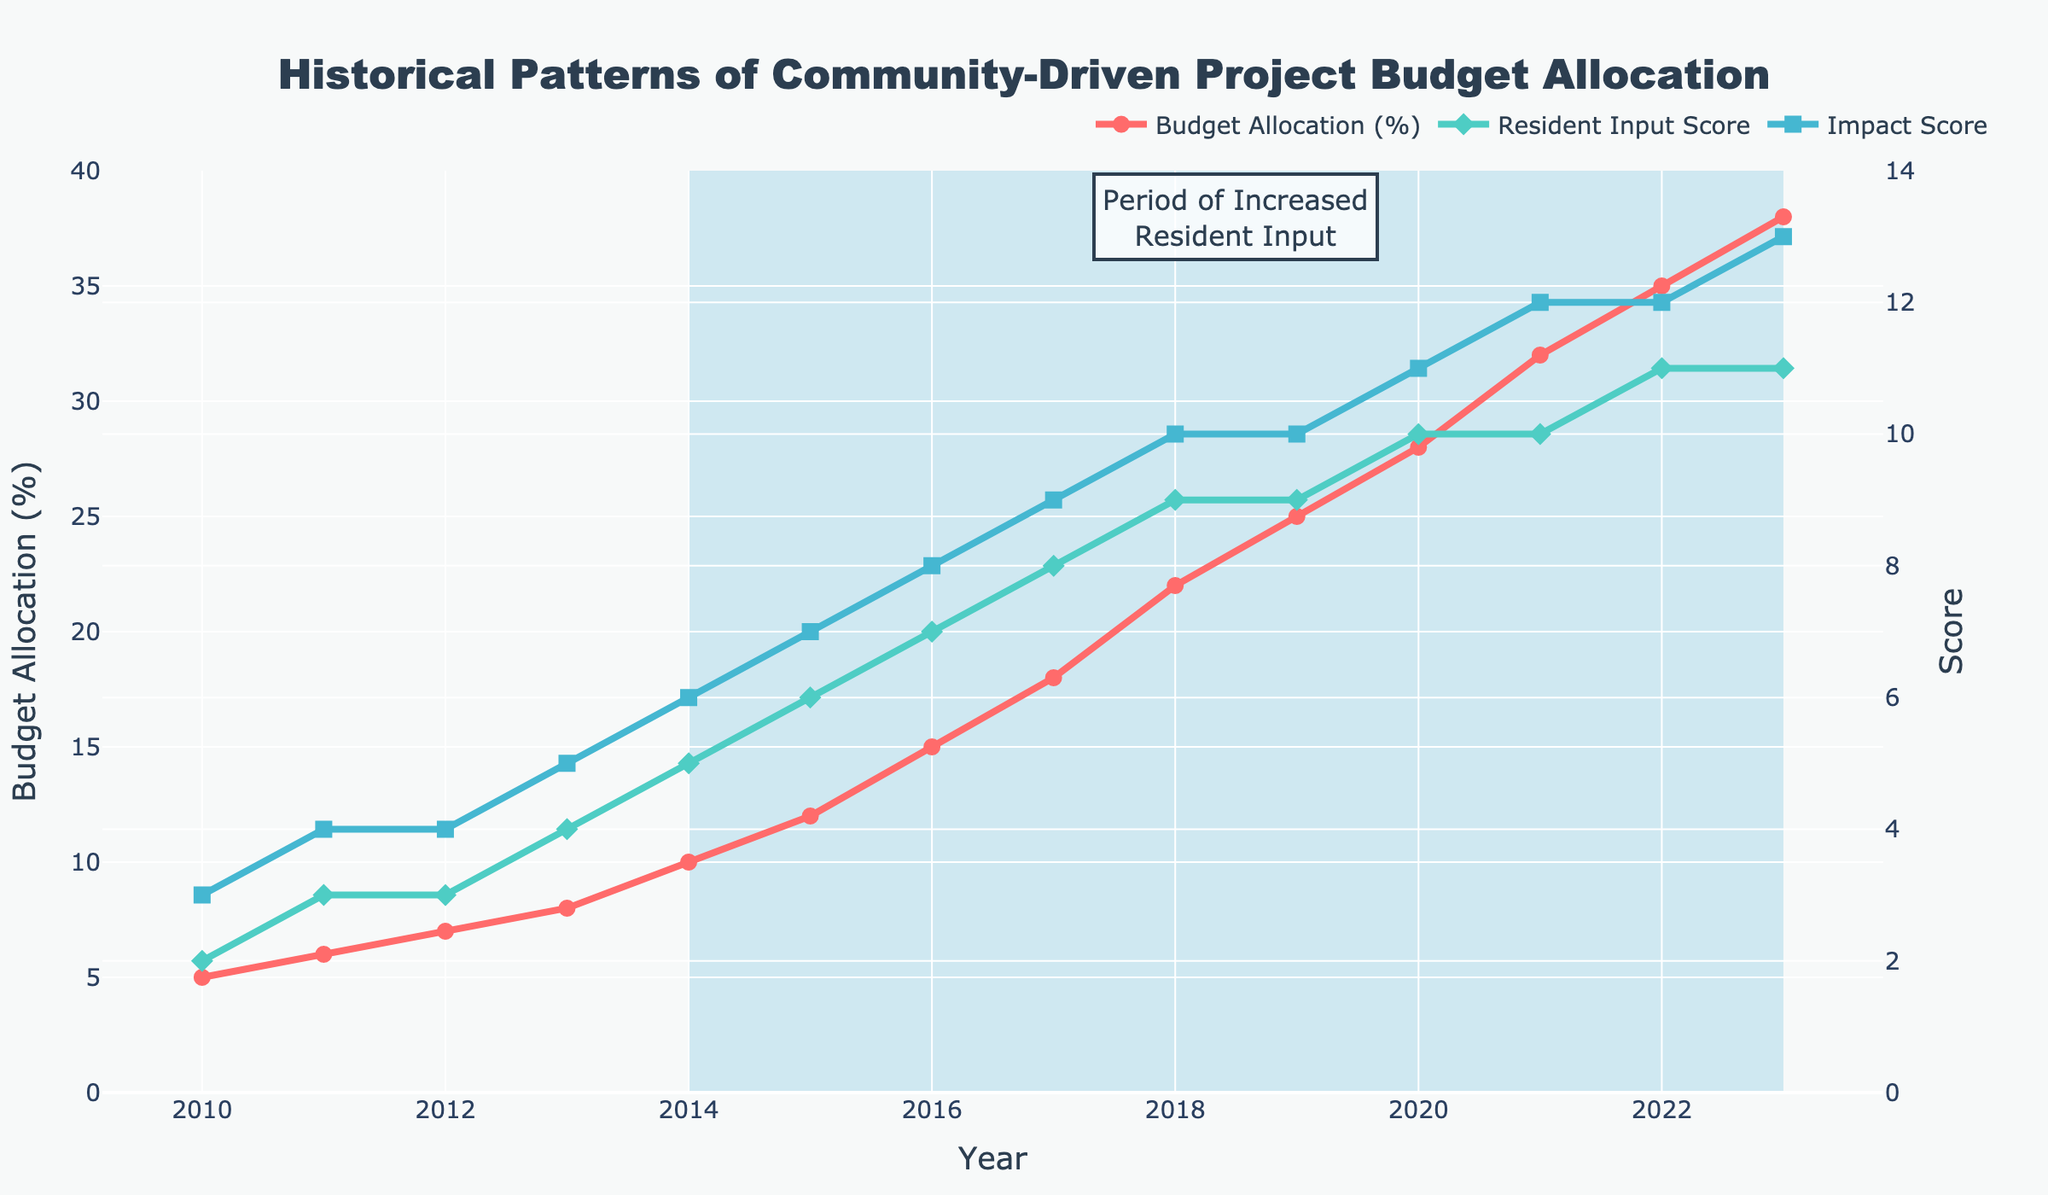Which year had the highest budget allocation percentage? From the y-axis titled "Budget Allocation (%)", we observe the line plot representing budget allocation. The line reaches its highest point at the year value of 2023.
Answer: 2023 From 2014 to 2019, by how much did the resident input score increase? The resident input score in 2014 is 5, and in 2019, it is 9. The increase is 9 - 5 = 4.
Answer: 4 Compare the budget allocation percentage and resident input score in 2010. Which one is higher, and by how much? In 2010, the budget allocation percentage is 5%, and the resident input score is 2. Comparing the two, 5% - 2 = 3%. Thus, the budget allocation percentage is higher by 3%.
Answer: Budget allocation percentage, 3% What is the overall trend observed in budget allocation from 2010 to 2023? Observing the red line on the chart representing budget allocation (%) over the years, there is a clear upward trend, with budget allocation increasing consistently from 2010 to 2023.
Answer: Increasing trend What is the average impact score from 2017 to 2020? The impact scores from 2017 to 2020 are 9, 10, 10, and 11. Summing these scores gives 9 + 10 + 10 + 11 = 40. The average is 40 / 4 = 10.
Answer: 10 Which period showed the most significant increase in budget allocation percentage? By examining the highlighted area and the steepness of the red line, the period from 2016 to 2018 shows the most significant increase, with budget allocation rising from 15% to 22%.
Answer: 2016 to 2018 Between which two consecutive years did the resident input score remain constant? The green line representing the resident input score appears to remain constant between 2018 and 2019, with both years having a score of 9.
Answer: 2018 and 2019 Compare the impact score in 2015 and 2023. How much greater is the impact score in 2023 than in 2015? The impact score in 2015 is 7, while in 2023 it is 13. The difference is 13 - 7 = 6.
Answer: 6 What can you infer about the relationship between budget allocation percentage and resident input score over the period 2010-2023? Both the budget allocation percentage (red line) and the resident input score (green line) show an upward trend over time. This suggests that increased resident input correlates with higher budget allocation for community-driven projects.
Answer: Correlated increase 